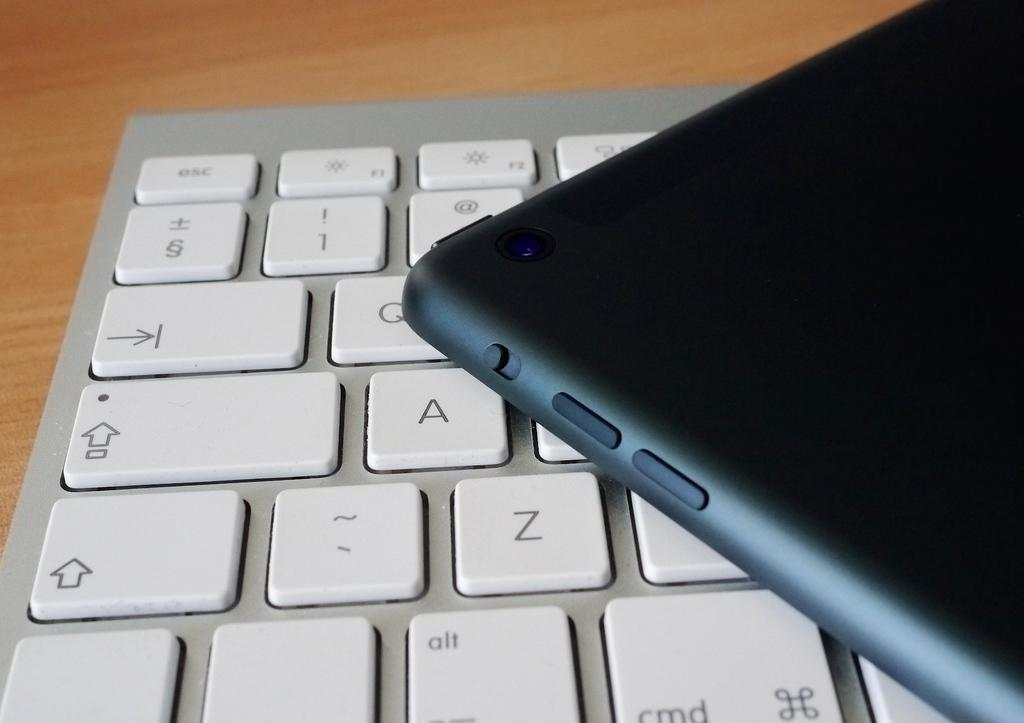<image>
Relay a brief, clear account of the picture shown. A cell phone sitting on a computer keyboard with keys A, Z, and Q visible 